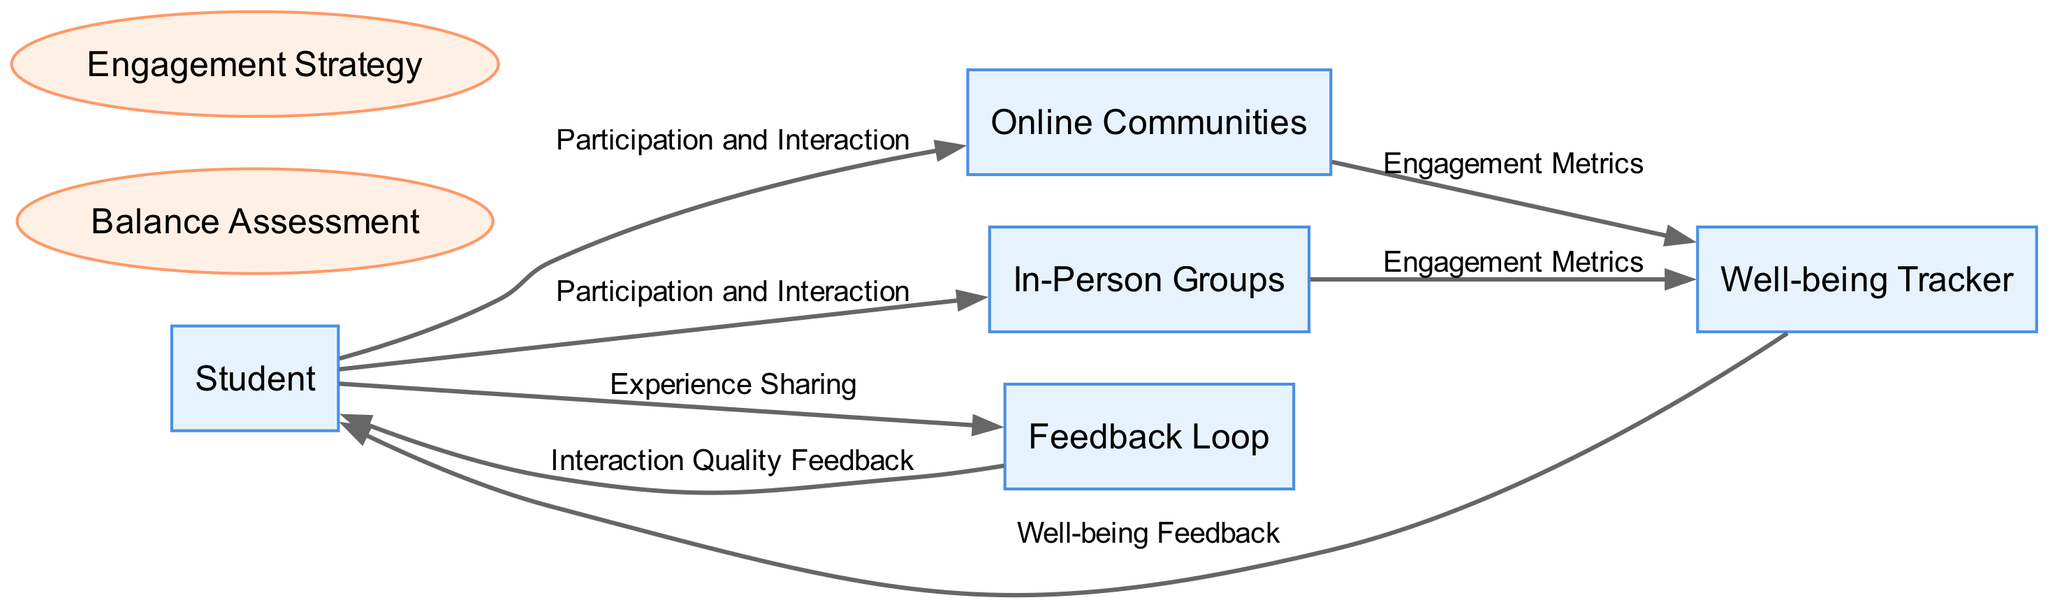What are the two primary types of engagement the student is managing? The diagram lists "Online Communities" and "In-Person Groups" as the two types of social interactions the student is balancing, directly related to the entities present.
Answer: Online Communities, In-Person Groups How many data flows are present in the diagram? By counting the lines connecting different nodes, there are six distinct data flows, which represent the interaction between entities and processes in the diagram.
Answer: 6 What feedback does the Well-being Tracker provide to the Student? The Well-being Tracker sends "Well-being Feedback" to the Student, indicating insights on their mental and physical health regarding social interactions.
Answer: Well-being Feedback Which process involves assessing interactions? The process that focuses on evaluating the balance between online and in-person interactions is titled "Balance Assessment", which describes the necessary actions the student undertakes to analyze their engagement levels.
Answer: Balance Assessment What does the Student provide to the Feedback Loop? The Student shares "Experience Sharing" with the Feedback Loop, which allows them to communicate their feelings and reflections on their social interactions to improve future engagements.
Answer: Experience Sharing How do Online Communities contribute to the Well-being Tracker? Online Communities send "Engagement Metrics" to the Well-being Tracker, which captures data about the student's interaction levels and duration spent on these online platforms for further analysis.
Answer: Engagement Metrics Which entity is the main user in the diagram? The main user identified in the diagram is labeled as "Student", representing the individual trying to balance their social lives through different engagement platforms.
Answer: Student What does the Feedback Loop deliver to the Student? The Feedback Loop provides "Interaction Quality Feedback" to the Student, which helps them understand the quality of their interactions and make adjustments to future engagements.
Answer: Interaction Quality Feedback How does the In-Person Groups affect the Well-being Tracker? In-Person Groups contribute "Engagement Metrics" to the Well-being Tracker, similar to how Online Communities do, measuring the student's interaction levels and time spent in physical engagements.
Answer: Engagement Metrics 